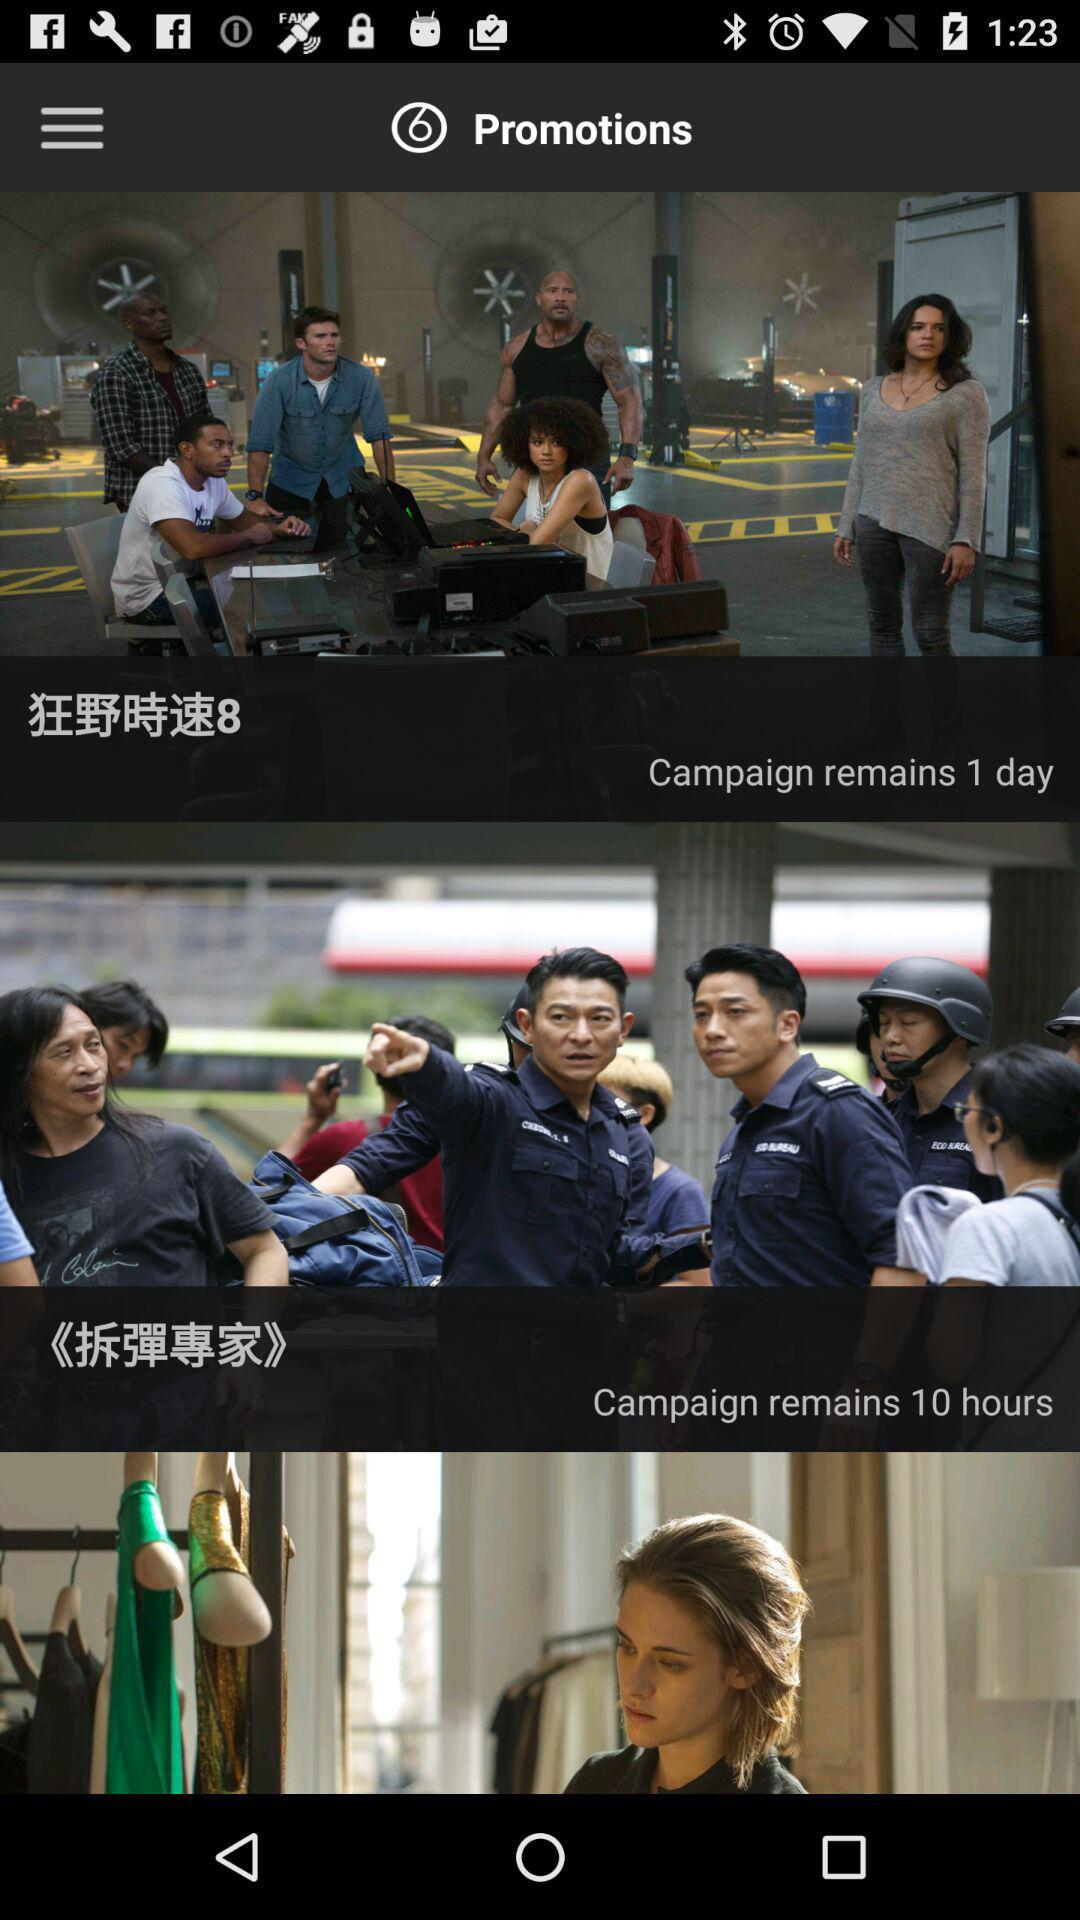What is the number of remaining campaign days? The number of remaining campaign days is 1. 